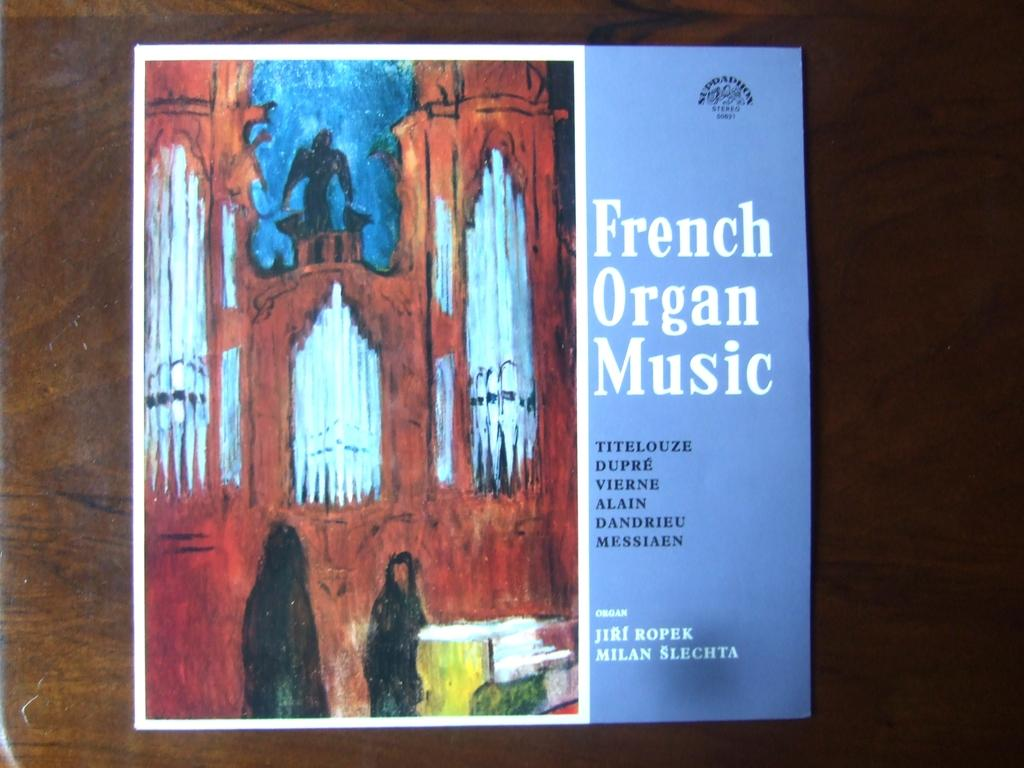<image>
Offer a succinct explanation of the picture presented. An album of French Organ Music with a blue color and picture of a cathedral. 